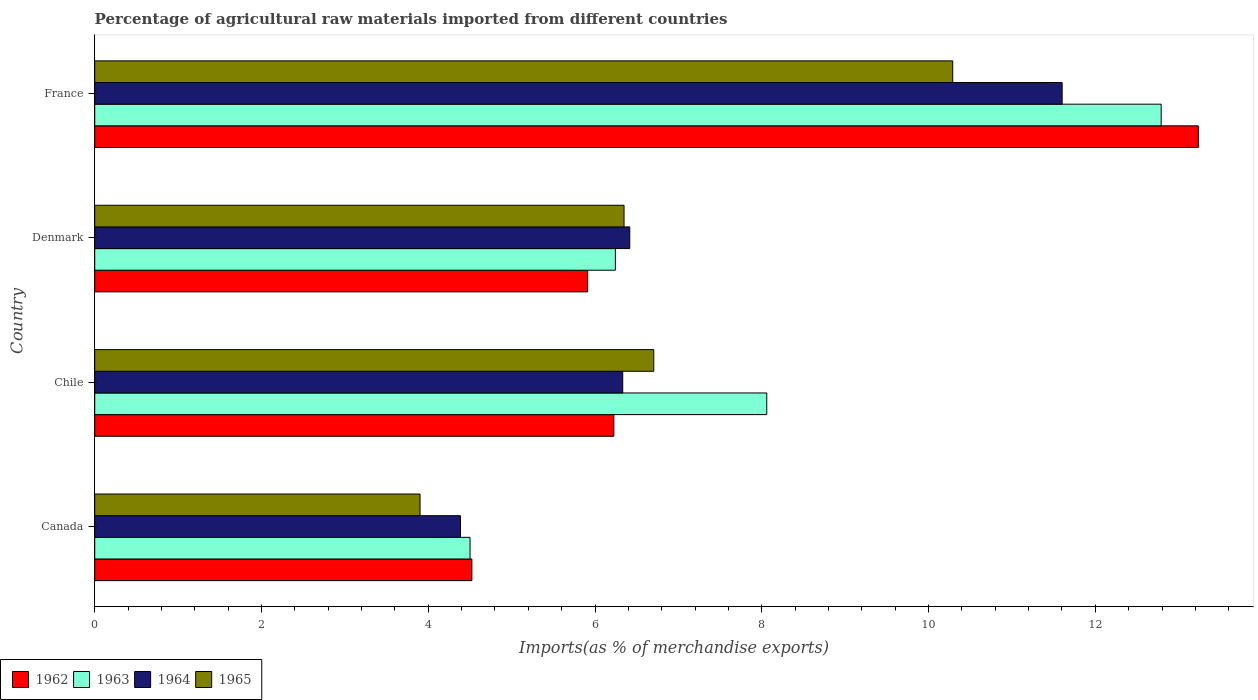How many different coloured bars are there?
Keep it short and to the point. 4. How many groups of bars are there?
Your response must be concise. 4. Are the number of bars on each tick of the Y-axis equal?
Make the answer very short. Yes. What is the percentage of imports to different countries in 1963 in Chile?
Offer a terse response. 8.06. Across all countries, what is the maximum percentage of imports to different countries in 1963?
Your answer should be very brief. 12.79. Across all countries, what is the minimum percentage of imports to different countries in 1963?
Provide a short and direct response. 4.5. In which country was the percentage of imports to different countries in 1964 maximum?
Your answer should be very brief. France. What is the total percentage of imports to different countries in 1963 in the graph?
Provide a short and direct response. 31.59. What is the difference between the percentage of imports to different countries in 1963 in Chile and that in France?
Ensure brevity in your answer.  -4.73. What is the difference between the percentage of imports to different countries in 1962 in France and the percentage of imports to different countries in 1964 in Denmark?
Your response must be concise. 6.82. What is the average percentage of imports to different countries in 1965 per country?
Keep it short and to the point. 6.81. What is the difference between the percentage of imports to different countries in 1963 and percentage of imports to different countries in 1965 in Chile?
Your response must be concise. 1.35. In how many countries, is the percentage of imports to different countries in 1962 greater than 7.2 %?
Make the answer very short. 1. What is the ratio of the percentage of imports to different countries in 1963 in Chile to that in France?
Provide a succinct answer. 0.63. Is the percentage of imports to different countries in 1963 in Denmark less than that in France?
Your response must be concise. Yes. Is the difference between the percentage of imports to different countries in 1963 in Chile and France greater than the difference between the percentage of imports to different countries in 1965 in Chile and France?
Provide a succinct answer. No. What is the difference between the highest and the second highest percentage of imports to different countries in 1962?
Keep it short and to the point. 7.01. What is the difference between the highest and the lowest percentage of imports to different countries in 1965?
Offer a very short reply. 6.39. In how many countries, is the percentage of imports to different countries in 1964 greater than the average percentage of imports to different countries in 1964 taken over all countries?
Make the answer very short. 1. Is the sum of the percentage of imports to different countries in 1962 in Chile and Denmark greater than the maximum percentage of imports to different countries in 1963 across all countries?
Your response must be concise. No. Is it the case that in every country, the sum of the percentage of imports to different countries in 1965 and percentage of imports to different countries in 1963 is greater than the sum of percentage of imports to different countries in 1962 and percentage of imports to different countries in 1964?
Make the answer very short. No. What does the 4th bar from the bottom in Canada represents?
Your response must be concise. 1965. Is it the case that in every country, the sum of the percentage of imports to different countries in 1965 and percentage of imports to different countries in 1962 is greater than the percentage of imports to different countries in 1964?
Your answer should be compact. Yes. How many bars are there?
Keep it short and to the point. 16. Are all the bars in the graph horizontal?
Provide a short and direct response. Yes. Does the graph contain grids?
Give a very brief answer. No. How many legend labels are there?
Provide a short and direct response. 4. What is the title of the graph?
Your response must be concise. Percentage of agricultural raw materials imported from different countries. Does "1980" appear as one of the legend labels in the graph?
Provide a short and direct response. No. What is the label or title of the X-axis?
Give a very brief answer. Imports(as % of merchandise exports). What is the Imports(as % of merchandise exports) of 1962 in Canada?
Your response must be concise. 4.52. What is the Imports(as % of merchandise exports) of 1963 in Canada?
Your response must be concise. 4.5. What is the Imports(as % of merchandise exports) of 1964 in Canada?
Ensure brevity in your answer.  4.39. What is the Imports(as % of merchandise exports) of 1965 in Canada?
Offer a terse response. 3.9. What is the Imports(as % of merchandise exports) in 1962 in Chile?
Your answer should be compact. 6.23. What is the Imports(as % of merchandise exports) in 1963 in Chile?
Your answer should be very brief. 8.06. What is the Imports(as % of merchandise exports) of 1964 in Chile?
Keep it short and to the point. 6.33. What is the Imports(as % of merchandise exports) of 1965 in Chile?
Keep it short and to the point. 6.7. What is the Imports(as % of merchandise exports) in 1962 in Denmark?
Offer a terse response. 5.91. What is the Imports(as % of merchandise exports) of 1963 in Denmark?
Provide a succinct answer. 6.24. What is the Imports(as % of merchandise exports) in 1964 in Denmark?
Give a very brief answer. 6.42. What is the Imports(as % of merchandise exports) in 1965 in Denmark?
Provide a short and direct response. 6.35. What is the Imports(as % of merchandise exports) of 1962 in France?
Make the answer very short. 13.24. What is the Imports(as % of merchandise exports) in 1963 in France?
Keep it short and to the point. 12.79. What is the Imports(as % of merchandise exports) in 1964 in France?
Your answer should be compact. 11.6. What is the Imports(as % of merchandise exports) of 1965 in France?
Your answer should be compact. 10.29. Across all countries, what is the maximum Imports(as % of merchandise exports) of 1962?
Your response must be concise. 13.24. Across all countries, what is the maximum Imports(as % of merchandise exports) of 1963?
Make the answer very short. 12.79. Across all countries, what is the maximum Imports(as % of merchandise exports) of 1964?
Your response must be concise. 11.6. Across all countries, what is the maximum Imports(as % of merchandise exports) of 1965?
Your response must be concise. 10.29. Across all countries, what is the minimum Imports(as % of merchandise exports) in 1962?
Your answer should be very brief. 4.52. Across all countries, what is the minimum Imports(as % of merchandise exports) in 1963?
Give a very brief answer. 4.5. Across all countries, what is the minimum Imports(as % of merchandise exports) in 1964?
Give a very brief answer. 4.39. Across all countries, what is the minimum Imports(as % of merchandise exports) of 1965?
Provide a short and direct response. 3.9. What is the total Imports(as % of merchandise exports) of 1962 in the graph?
Offer a terse response. 29.9. What is the total Imports(as % of merchandise exports) of 1963 in the graph?
Ensure brevity in your answer.  31.59. What is the total Imports(as % of merchandise exports) of 1964 in the graph?
Offer a terse response. 28.74. What is the total Imports(as % of merchandise exports) in 1965 in the graph?
Make the answer very short. 27.24. What is the difference between the Imports(as % of merchandise exports) of 1962 in Canada and that in Chile?
Offer a very short reply. -1.7. What is the difference between the Imports(as % of merchandise exports) in 1963 in Canada and that in Chile?
Make the answer very short. -3.56. What is the difference between the Imports(as % of merchandise exports) in 1964 in Canada and that in Chile?
Ensure brevity in your answer.  -1.95. What is the difference between the Imports(as % of merchandise exports) in 1965 in Canada and that in Chile?
Give a very brief answer. -2.8. What is the difference between the Imports(as % of merchandise exports) of 1962 in Canada and that in Denmark?
Ensure brevity in your answer.  -1.39. What is the difference between the Imports(as % of merchandise exports) of 1963 in Canada and that in Denmark?
Provide a short and direct response. -1.74. What is the difference between the Imports(as % of merchandise exports) of 1964 in Canada and that in Denmark?
Keep it short and to the point. -2.03. What is the difference between the Imports(as % of merchandise exports) in 1965 in Canada and that in Denmark?
Give a very brief answer. -2.45. What is the difference between the Imports(as % of merchandise exports) of 1962 in Canada and that in France?
Give a very brief answer. -8.71. What is the difference between the Imports(as % of merchandise exports) of 1963 in Canada and that in France?
Offer a very short reply. -8.29. What is the difference between the Imports(as % of merchandise exports) of 1964 in Canada and that in France?
Provide a short and direct response. -7.22. What is the difference between the Imports(as % of merchandise exports) of 1965 in Canada and that in France?
Keep it short and to the point. -6.39. What is the difference between the Imports(as % of merchandise exports) in 1962 in Chile and that in Denmark?
Offer a very short reply. 0.31. What is the difference between the Imports(as % of merchandise exports) of 1963 in Chile and that in Denmark?
Keep it short and to the point. 1.82. What is the difference between the Imports(as % of merchandise exports) of 1964 in Chile and that in Denmark?
Ensure brevity in your answer.  -0.08. What is the difference between the Imports(as % of merchandise exports) of 1965 in Chile and that in Denmark?
Offer a very short reply. 0.36. What is the difference between the Imports(as % of merchandise exports) in 1962 in Chile and that in France?
Give a very brief answer. -7.01. What is the difference between the Imports(as % of merchandise exports) in 1963 in Chile and that in France?
Give a very brief answer. -4.73. What is the difference between the Imports(as % of merchandise exports) in 1964 in Chile and that in France?
Your answer should be compact. -5.27. What is the difference between the Imports(as % of merchandise exports) of 1965 in Chile and that in France?
Provide a succinct answer. -3.59. What is the difference between the Imports(as % of merchandise exports) in 1962 in Denmark and that in France?
Provide a short and direct response. -7.32. What is the difference between the Imports(as % of merchandise exports) in 1963 in Denmark and that in France?
Give a very brief answer. -6.55. What is the difference between the Imports(as % of merchandise exports) of 1964 in Denmark and that in France?
Provide a succinct answer. -5.19. What is the difference between the Imports(as % of merchandise exports) in 1965 in Denmark and that in France?
Keep it short and to the point. -3.94. What is the difference between the Imports(as % of merchandise exports) of 1962 in Canada and the Imports(as % of merchandise exports) of 1963 in Chile?
Ensure brevity in your answer.  -3.54. What is the difference between the Imports(as % of merchandise exports) in 1962 in Canada and the Imports(as % of merchandise exports) in 1964 in Chile?
Provide a succinct answer. -1.81. What is the difference between the Imports(as % of merchandise exports) of 1962 in Canada and the Imports(as % of merchandise exports) of 1965 in Chile?
Your response must be concise. -2.18. What is the difference between the Imports(as % of merchandise exports) in 1963 in Canada and the Imports(as % of merchandise exports) in 1964 in Chile?
Your answer should be very brief. -1.83. What is the difference between the Imports(as % of merchandise exports) of 1963 in Canada and the Imports(as % of merchandise exports) of 1965 in Chile?
Offer a very short reply. -2.2. What is the difference between the Imports(as % of merchandise exports) of 1964 in Canada and the Imports(as % of merchandise exports) of 1965 in Chile?
Offer a very short reply. -2.32. What is the difference between the Imports(as % of merchandise exports) of 1962 in Canada and the Imports(as % of merchandise exports) of 1963 in Denmark?
Offer a terse response. -1.72. What is the difference between the Imports(as % of merchandise exports) of 1962 in Canada and the Imports(as % of merchandise exports) of 1964 in Denmark?
Offer a terse response. -1.89. What is the difference between the Imports(as % of merchandise exports) of 1962 in Canada and the Imports(as % of merchandise exports) of 1965 in Denmark?
Offer a terse response. -1.83. What is the difference between the Imports(as % of merchandise exports) in 1963 in Canada and the Imports(as % of merchandise exports) in 1964 in Denmark?
Your answer should be very brief. -1.92. What is the difference between the Imports(as % of merchandise exports) in 1963 in Canada and the Imports(as % of merchandise exports) in 1965 in Denmark?
Offer a very short reply. -1.85. What is the difference between the Imports(as % of merchandise exports) in 1964 in Canada and the Imports(as % of merchandise exports) in 1965 in Denmark?
Provide a short and direct response. -1.96. What is the difference between the Imports(as % of merchandise exports) of 1962 in Canada and the Imports(as % of merchandise exports) of 1963 in France?
Your response must be concise. -8.27. What is the difference between the Imports(as % of merchandise exports) of 1962 in Canada and the Imports(as % of merchandise exports) of 1964 in France?
Give a very brief answer. -7.08. What is the difference between the Imports(as % of merchandise exports) of 1962 in Canada and the Imports(as % of merchandise exports) of 1965 in France?
Your answer should be very brief. -5.77. What is the difference between the Imports(as % of merchandise exports) in 1963 in Canada and the Imports(as % of merchandise exports) in 1964 in France?
Make the answer very short. -7.1. What is the difference between the Imports(as % of merchandise exports) of 1963 in Canada and the Imports(as % of merchandise exports) of 1965 in France?
Make the answer very short. -5.79. What is the difference between the Imports(as % of merchandise exports) of 1964 in Canada and the Imports(as % of merchandise exports) of 1965 in France?
Your response must be concise. -5.9. What is the difference between the Imports(as % of merchandise exports) of 1962 in Chile and the Imports(as % of merchandise exports) of 1963 in Denmark?
Your response must be concise. -0.02. What is the difference between the Imports(as % of merchandise exports) in 1962 in Chile and the Imports(as % of merchandise exports) in 1964 in Denmark?
Offer a terse response. -0.19. What is the difference between the Imports(as % of merchandise exports) in 1962 in Chile and the Imports(as % of merchandise exports) in 1965 in Denmark?
Keep it short and to the point. -0.12. What is the difference between the Imports(as % of merchandise exports) of 1963 in Chile and the Imports(as % of merchandise exports) of 1964 in Denmark?
Your answer should be very brief. 1.64. What is the difference between the Imports(as % of merchandise exports) in 1963 in Chile and the Imports(as % of merchandise exports) in 1965 in Denmark?
Provide a short and direct response. 1.71. What is the difference between the Imports(as % of merchandise exports) of 1964 in Chile and the Imports(as % of merchandise exports) of 1965 in Denmark?
Your answer should be compact. -0.02. What is the difference between the Imports(as % of merchandise exports) of 1962 in Chile and the Imports(as % of merchandise exports) of 1963 in France?
Make the answer very short. -6.56. What is the difference between the Imports(as % of merchandise exports) of 1962 in Chile and the Imports(as % of merchandise exports) of 1964 in France?
Offer a terse response. -5.38. What is the difference between the Imports(as % of merchandise exports) in 1962 in Chile and the Imports(as % of merchandise exports) in 1965 in France?
Ensure brevity in your answer.  -4.06. What is the difference between the Imports(as % of merchandise exports) in 1963 in Chile and the Imports(as % of merchandise exports) in 1964 in France?
Give a very brief answer. -3.54. What is the difference between the Imports(as % of merchandise exports) in 1963 in Chile and the Imports(as % of merchandise exports) in 1965 in France?
Your answer should be very brief. -2.23. What is the difference between the Imports(as % of merchandise exports) in 1964 in Chile and the Imports(as % of merchandise exports) in 1965 in France?
Provide a succinct answer. -3.96. What is the difference between the Imports(as % of merchandise exports) of 1962 in Denmark and the Imports(as % of merchandise exports) of 1963 in France?
Offer a terse response. -6.88. What is the difference between the Imports(as % of merchandise exports) in 1962 in Denmark and the Imports(as % of merchandise exports) in 1964 in France?
Keep it short and to the point. -5.69. What is the difference between the Imports(as % of merchandise exports) in 1962 in Denmark and the Imports(as % of merchandise exports) in 1965 in France?
Ensure brevity in your answer.  -4.38. What is the difference between the Imports(as % of merchandise exports) in 1963 in Denmark and the Imports(as % of merchandise exports) in 1964 in France?
Your response must be concise. -5.36. What is the difference between the Imports(as % of merchandise exports) of 1963 in Denmark and the Imports(as % of merchandise exports) of 1965 in France?
Your response must be concise. -4.05. What is the difference between the Imports(as % of merchandise exports) in 1964 in Denmark and the Imports(as % of merchandise exports) in 1965 in France?
Your answer should be compact. -3.87. What is the average Imports(as % of merchandise exports) of 1962 per country?
Keep it short and to the point. 7.47. What is the average Imports(as % of merchandise exports) of 1963 per country?
Your answer should be very brief. 7.9. What is the average Imports(as % of merchandise exports) of 1964 per country?
Ensure brevity in your answer.  7.18. What is the average Imports(as % of merchandise exports) of 1965 per country?
Your response must be concise. 6.81. What is the difference between the Imports(as % of merchandise exports) of 1962 and Imports(as % of merchandise exports) of 1963 in Canada?
Provide a succinct answer. 0.02. What is the difference between the Imports(as % of merchandise exports) in 1962 and Imports(as % of merchandise exports) in 1964 in Canada?
Your answer should be compact. 0.14. What is the difference between the Imports(as % of merchandise exports) of 1962 and Imports(as % of merchandise exports) of 1965 in Canada?
Ensure brevity in your answer.  0.62. What is the difference between the Imports(as % of merchandise exports) in 1963 and Imports(as % of merchandise exports) in 1964 in Canada?
Offer a terse response. 0.12. What is the difference between the Imports(as % of merchandise exports) in 1963 and Imports(as % of merchandise exports) in 1965 in Canada?
Your response must be concise. 0.6. What is the difference between the Imports(as % of merchandise exports) in 1964 and Imports(as % of merchandise exports) in 1965 in Canada?
Make the answer very short. 0.48. What is the difference between the Imports(as % of merchandise exports) of 1962 and Imports(as % of merchandise exports) of 1963 in Chile?
Offer a very short reply. -1.83. What is the difference between the Imports(as % of merchandise exports) of 1962 and Imports(as % of merchandise exports) of 1964 in Chile?
Offer a terse response. -0.11. What is the difference between the Imports(as % of merchandise exports) in 1962 and Imports(as % of merchandise exports) in 1965 in Chile?
Provide a succinct answer. -0.48. What is the difference between the Imports(as % of merchandise exports) of 1963 and Imports(as % of merchandise exports) of 1964 in Chile?
Keep it short and to the point. 1.73. What is the difference between the Imports(as % of merchandise exports) of 1963 and Imports(as % of merchandise exports) of 1965 in Chile?
Ensure brevity in your answer.  1.35. What is the difference between the Imports(as % of merchandise exports) of 1964 and Imports(as % of merchandise exports) of 1965 in Chile?
Keep it short and to the point. -0.37. What is the difference between the Imports(as % of merchandise exports) in 1962 and Imports(as % of merchandise exports) in 1963 in Denmark?
Offer a very short reply. -0.33. What is the difference between the Imports(as % of merchandise exports) of 1962 and Imports(as % of merchandise exports) of 1964 in Denmark?
Keep it short and to the point. -0.51. What is the difference between the Imports(as % of merchandise exports) in 1962 and Imports(as % of merchandise exports) in 1965 in Denmark?
Offer a very short reply. -0.44. What is the difference between the Imports(as % of merchandise exports) of 1963 and Imports(as % of merchandise exports) of 1964 in Denmark?
Your response must be concise. -0.17. What is the difference between the Imports(as % of merchandise exports) of 1963 and Imports(as % of merchandise exports) of 1965 in Denmark?
Offer a terse response. -0.1. What is the difference between the Imports(as % of merchandise exports) in 1964 and Imports(as % of merchandise exports) in 1965 in Denmark?
Provide a succinct answer. 0.07. What is the difference between the Imports(as % of merchandise exports) of 1962 and Imports(as % of merchandise exports) of 1963 in France?
Ensure brevity in your answer.  0.45. What is the difference between the Imports(as % of merchandise exports) in 1962 and Imports(as % of merchandise exports) in 1964 in France?
Make the answer very short. 1.63. What is the difference between the Imports(as % of merchandise exports) of 1962 and Imports(as % of merchandise exports) of 1965 in France?
Provide a short and direct response. 2.95. What is the difference between the Imports(as % of merchandise exports) of 1963 and Imports(as % of merchandise exports) of 1964 in France?
Give a very brief answer. 1.19. What is the difference between the Imports(as % of merchandise exports) in 1963 and Imports(as % of merchandise exports) in 1965 in France?
Keep it short and to the point. 2.5. What is the difference between the Imports(as % of merchandise exports) of 1964 and Imports(as % of merchandise exports) of 1965 in France?
Your response must be concise. 1.31. What is the ratio of the Imports(as % of merchandise exports) in 1962 in Canada to that in Chile?
Ensure brevity in your answer.  0.73. What is the ratio of the Imports(as % of merchandise exports) in 1963 in Canada to that in Chile?
Your answer should be compact. 0.56. What is the ratio of the Imports(as % of merchandise exports) in 1964 in Canada to that in Chile?
Keep it short and to the point. 0.69. What is the ratio of the Imports(as % of merchandise exports) in 1965 in Canada to that in Chile?
Your answer should be compact. 0.58. What is the ratio of the Imports(as % of merchandise exports) in 1962 in Canada to that in Denmark?
Your response must be concise. 0.77. What is the ratio of the Imports(as % of merchandise exports) in 1963 in Canada to that in Denmark?
Offer a terse response. 0.72. What is the ratio of the Imports(as % of merchandise exports) in 1964 in Canada to that in Denmark?
Ensure brevity in your answer.  0.68. What is the ratio of the Imports(as % of merchandise exports) in 1965 in Canada to that in Denmark?
Your response must be concise. 0.61. What is the ratio of the Imports(as % of merchandise exports) of 1962 in Canada to that in France?
Your answer should be compact. 0.34. What is the ratio of the Imports(as % of merchandise exports) of 1963 in Canada to that in France?
Offer a very short reply. 0.35. What is the ratio of the Imports(as % of merchandise exports) in 1964 in Canada to that in France?
Make the answer very short. 0.38. What is the ratio of the Imports(as % of merchandise exports) of 1965 in Canada to that in France?
Offer a terse response. 0.38. What is the ratio of the Imports(as % of merchandise exports) in 1962 in Chile to that in Denmark?
Offer a very short reply. 1.05. What is the ratio of the Imports(as % of merchandise exports) of 1963 in Chile to that in Denmark?
Your response must be concise. 1.29. What is the ratio of the Imports(as % of merchandise exports) in 1965 in Chile to that in Denmark?
Your answer should be very brief. 1.06. What is the ratio of the Imports(as % of merchandise exports) in 1962 in Chile to that in France?
Provide a short and direct response. 0.47. What is the ratio of the Imports(as % of merchandise exports) of 1963 in Chile to that in France?
Your answer should be very brief. 0.63. What is the ratio of the Imports(as % of merchandise exports) of 1964 in Chile to that in France?
Provide a short and direct response. 0.55. What is the ratio of the Imports(as % of merchandise exports) in 1965 in Chile to that in France?
Offer a very short reply. 0.65. What is the ratio of the Imports(as % of merchandise exports) in 1962 in Denmark to that in France?
Your answer should be compact. 0.45. What is the ratio of the Imports(as % of merchandise exports) in 1963 in Denmark to that in France?
Your answer should be compact. 0.49. What is the ratio of the Imports(as % of merchandise exports) of 1964 in Denmark to that in France?
Your answer should be very brief. 0.55. What is the ratio of the Imports(as % of merchandise exports) of 1965 in Denmark to that in France?
Provide a succinct answer. 0.62. What is the difference between the highest and the second highest Imports(as % of merchandise exports) in 1962?
Offer a terse response. 7.01. What is the difference between the highest and the second highest Imports(as % of merchandise exports) in 1963?
Offer a terse response. 4.73. What is the difference between the highest and the second highest Imports(as % of merchandise exports) in 1964?
Keep it short and to the point. 5.19. What is the difference between the highest and the second highest Imports(as % of merchandise exports) in 1965?
Offer a terse response. 3.59. What is the difference between the highest and the lowest Imports(as % of merchandise exports) in 1962?
Provide a short and direct response. 8.71. What is the difference between the highest and the lowest Imports(as % of merchandise exports) of 1963?
Offer a very short reply. 8.29. What is the difference between the highest and the lowest Imports(as % of merchandise exports) of 1964?
Make the answer very short. 7.22. What is the difference between the highest and the lowest Imports(as % of merchandise exports) of 1965?
Your response must be concise. 6.39. 